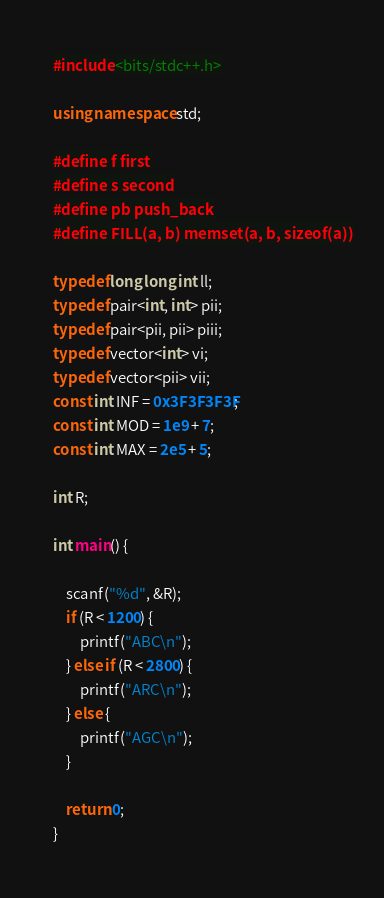<code> <loc_0><loc_0><loc_500><loc_500><_C++_>#include <bits/stdc++.h>

using namespace std;

#define f first
#define s second
#define pb push_back
#define FILL(a, b) memset(a, b, sizeof(a))

typedef long long int ll;
typedef pair<int, int> pii;
typedef pair<pii, pii> piii;
typedef vector<int> vi;
typedef vector<pii> vii;
const int INF = 0x3F3F3F3F;
const int MOD = 1e9 + 7;
const int MAX = 2e5 + 5;

int R;

int main() {
    
    scanf("%d", &R);
    if (R < 1200) {
        printf("ABC\n");
    } else if (R < 2800) {
        printf("ARC\n");
    } else {
        printf("AGC\n");
    }
    
    return 0;
}
</code> 